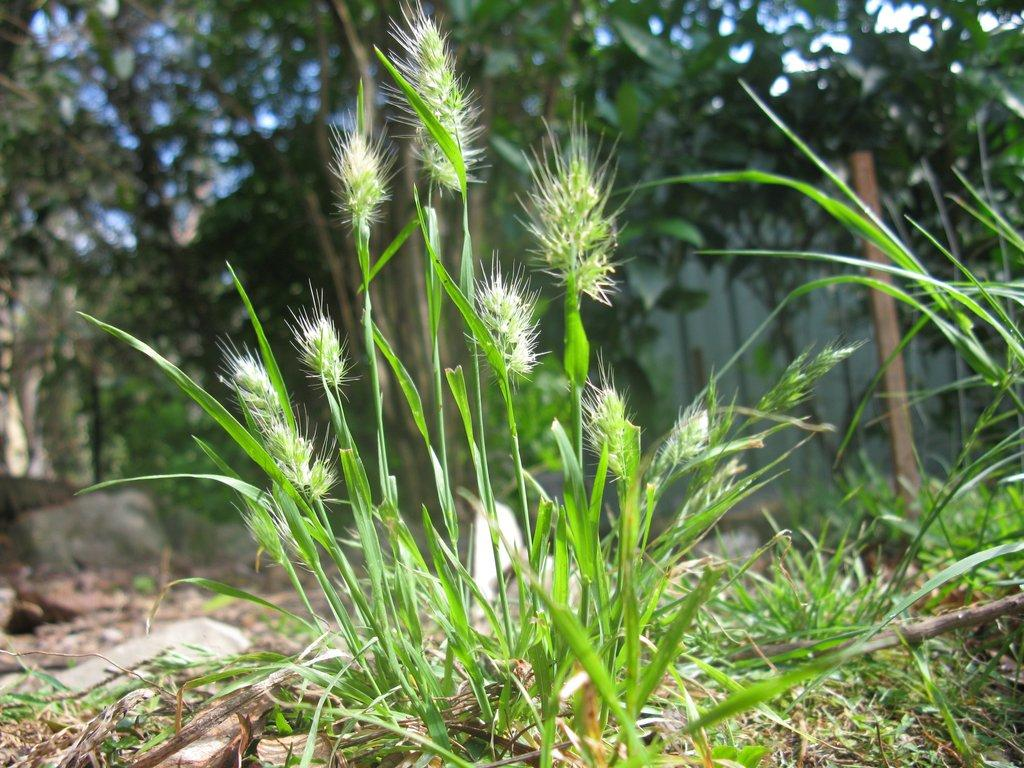What type of vegetation can be seen in the image? There are plants and grass in the image. What can be seen in the background of the image? There are trees, poles, and stones in the background of the image. What type of marble is visible in the image? There is no marble present in the image. How many times do the plants fall asleep in the image? Plants do not sleep, so this question cannot be answered. 